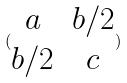Convert formula to latex. <formula><loc_0><loc_0><loc_500><loc_500>( \begin{matrix} a & b / 2 \\ b / 2 & c \end{matrix} )</formula> 